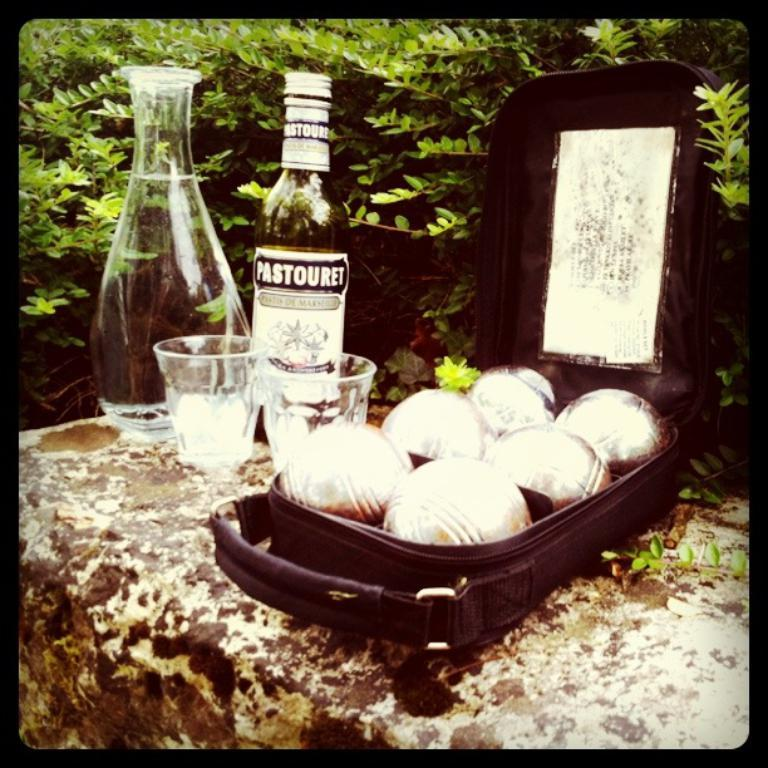Where was the image taken? The image is taken outdoors. What can be seen on the wall in the image? There is a jar, bottles, cups, and a box with food items on the wall. What is the purpose of the box with food items? The box with food items is likely for storage or display. What is visible behind the bottles on the wall? Trees are visible behind the bottles. Can you tell me how many caps are on the wall in the image? There is no mention of caps in the image, so it is not possible to determine how many caps are present. 